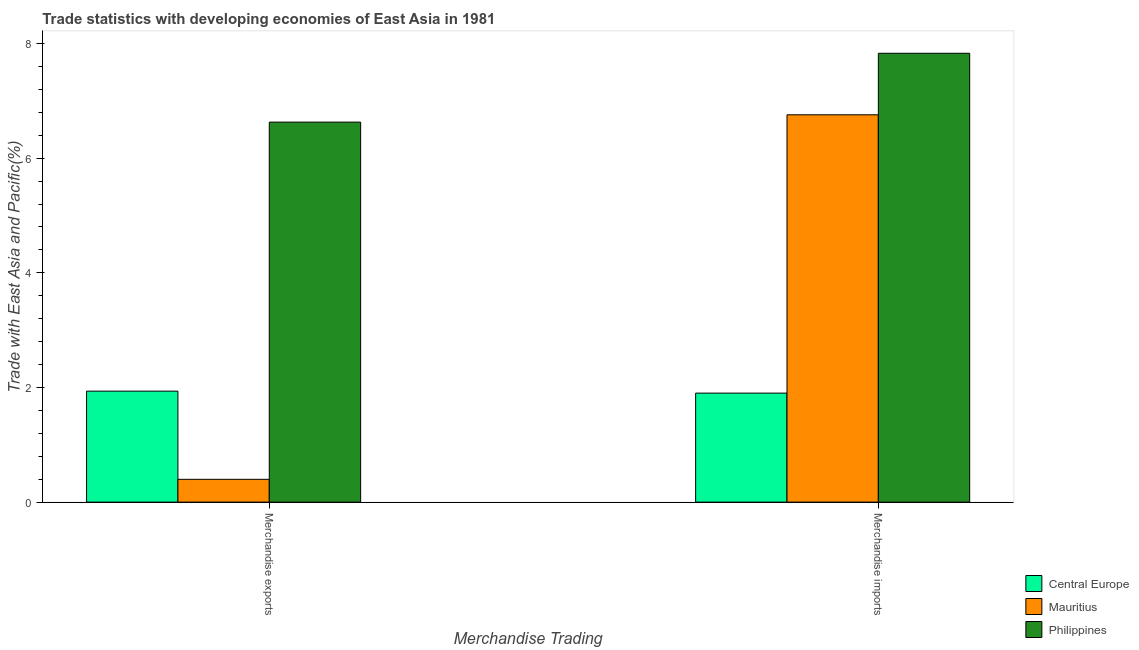How many groups of bars are there?
Give a very brief answer. 2. Are the number of bars per tick equal to the number of legend labels?
Ensure brevity in your answer.  Yes. Are the number of bars on each tick of the X-axis equal?
Keep it short and to the point. Yes. How many bars are there on the 1st tick from the right?
Your response must be concise. 3. What is the merchandise imports in Philippines?
Offer a very short reply. 7.83. Across all countries, what is the maximum merchandise exports?
Give a very brief answer. 6.63. Across all countries, what is the minimum merchandise exports?
Provide a short and direct response. 0.4. In which country was the merchandise imports maximum?
Your answer should be very brief. Philippines. In which country was the merchandise exports minimum?
Make the answer very short. Mauritius. What is the total merchandise exports in the graph?
Your answer should be very brief. 8.96. What is the difference between the merchandise imports in Philippines and that in Central Europe?
Offer a very short reply. 5.93. What is the difference between the merchandise imports in Mauritius and the merchandise exports in Central Europe?
Provide a succinct answer. 4.82. What is the average merchandise exports per country?
Ensure brevity in your answer.  2.99. What is the difference between the merchandise exports and merchandise imports in Mauritius?
Your response must be concise. -6.36. In how many countries, is the merchandise imports greater than 6.8 %?
Make the answer very short. 1. What is the ratio of the merchandise imports in Mauritius to that in Philippines?
Your answer should be compact. 0.86. Is the merchandise imports in Mauritius less than that in Philippines?
Your answer should be compact. Yes. What does the 2nd bar from the right in Merchandise exports represents?
Keep it short and to the point. Mauritius. Are all the bars in the graph horizontal?
Provide a succinct answer. No. Are the values on the major ticks of Y-axis written in scientific E-notation?
Provide a succinct answer. No. Does the graph contain any zero values?
Your answer should be compact. No. Where does the legend appear in the graph?
Offer a very short reply. Bottom right. How are the legend labels stacked?
Offer a terse response. Vertical. What is the title of the graph?
Your response must be concise. Trade statistics with developing economies of East Asia in 1981. Does "Japan" appear as one of the legend labels in the graph?
Offer a very short reply. No. What is the label or title of the X-axis?
Your answer should be compact. Merchandise Trading. What is the label or title of the Y-axis?
Provide a succinct answer. Trade with East Asia and Pacific(%). What is the Trade with East Asia and Pacific(%) in Central Europe in Merchandise exports?
Give a very brief answer. 1.94. What is the Trade with East Asia and Pacific(%) of Mauritius in Merchandise exports?
Your response must be concise. 0.4. What is the Trade with East Asia and Pacific(%) in Philippines in Merchandise exports?
Give a very brief answer. 6.63. What is the Trade with East Asia and Pacific(%) in Central Europe in Merchandise imports?
Keep it short and to the point. 1.9. What is the Trade with East Asia and Pacific(%) in Mauritius in Merchandise imports?
Your response must be concise. 6.76. What is the Trade with East Asia and Pacific(%) of Philippines in Merchandise imports?
Your answer should be compact. 7.83. Across all Merchandise Trading, what is the maximum Trade with East Asia and Pacific(%) in Central Europe?
Your response must be concise. 1.94. Across all Merchandise Trading, what is the maximum Trade with East Asia and Pacific(%) in Mauritius?
Your answer should be compact. 6.76. Across all Merchandise Trading, what is the maximum Trade with East Asia and Pacific(%) of Philippines?
Provide a succinct answer. 7.83. Across all Merchandise Trading, what is the minimum Trade with East Asia and Pacific(%) in Central Europe?
Provide a short and direct response. 1.9. Across all Merchandise Trading, what is the minimum Trade with East Asia and Pacific(%) in Mauritius?
Give a very brief answer. 0.4. Across all Merchandise Trading, what is the minimum Trade with East Asia and Pacific(%) in Philippines?
Make the answer very short. 6.63. What is the total Trade with East Asia and Pacific(%) of Central Europe in the graph?
Your response must be concise. 3.84. What is the total Trade with East Asia and Pacific(%) in Mauritius in the graph?
Provide a succinct answer. 7.15. What is the total Trade with East Asia and Pacific(%) of Philippines in the graph?
Make the answer very short. 14.46. What is the difference between the Trade with East Asia and Pacific(%) in Central Europe in Merchandise exports and that in Merchandise imports?
Your response must be concise. 0.03. What is the difference between the Trade with East Asia and Pacific(%) of Mauritius in Merchandise exports and that in Merchandise imports?
Offer a very short reply. -6.36. What is the difference between the Trade with East Asia and Pacific(%) of Philippines in Merchandise exports and that in Merchandise imports?
Your answer should be compact. -1.2. What is the difference between the Trade with East Asia and Pacific(%) of Central Europe in Merchandise exports and the Trade with East Asia and Pacific(%) of Mauritius in Merchandise imports?
Keep it short and to the point. -4.82. What is the difference between the Trade with East Asia and Pacific(%) in Central Europe in Merchandise exports and the Trade with East Asia and Pacific(%) in Philippines in Merchandise imports?
Offer a terse response. -5.89. What is the difference between the Trade with East Asia and Pacific(%) in Mauritius in Merchandise exports and the Trade with East Asia and Pacific(%) in Philippines in Merchandise imports?
Make the answer very short. -7.43. What is the average Trade with East Asia and Pacific(%) of Central Europe per Merchandise Trading?
Ensure brevity in your answer.  1.92. What is the average Trade with East Asia and Pacific(%) of Mauritius per Merchandise Trading?
Keep it short and to the point. 3.58. What is the average Trade with East Asia and Pacific(%) in Philippines per Merchandise Trading?
Ensure brevity in your answer.  7.23. What is the difference between the Trade with East Asia and Pacific(%) in Central Europe and Trade with East Asia and Pacific(%) in Mauritius in Merchandise exports?
Provide a succinct answer. 1.54. What is the difference between the Trade with East Asia and Pacific(%) of Central Europe and Trade with East Asia and Pacific(%) of Philippines in Merchandise exports?
Make the answer very short. -4.69. What is the difference between the Trade with East Asia and Pacific(%) of Mauritius and Trade with East Asia and Pacific(%) of Philippines in Merchandise exports?
Offer a very short reply. -6.23. What is the difference between the Trade with East Asia and Pacific(%) of Central Europe and Trade with East Asia and Pacific(%) of Mauritius in Merchandise imports?
Offer a terse response. -4.86. What is the difference between the Trade with East Asia and Pacific(%) of Central Europe and Trade with East Asia and Pacific(%) of Philippines in Merchandise imports?
Ensure brevity in your answer.  -5.93. What is the difference between the Trade with East Asia and Pacific(%) in Mauritius and Trade with East Asia and Pacific(%) in Philippines in Merchandise imports?
Provide a succinct answer. -1.07. What is the ratio of the Trade with East Asia and Pacific(%) in Central Europe in Merchandise exports to that in Merchandise imports?
Your answer should be very brief. 1.02. What is the ratio of the Trade with East Asia and Pacific(%) of Mauritius in Merchandise exports to that in Merchandise imports?
Provide a short and direct response. 0.06. What is the ratio of the Trade with East Asia and Pacific(%) of Philippines in Merchandise exports to that in Merchandise imports?
Your answer should be compact. 0.85. What is the difference between the highest and the second highest Trade with East Asia and Pacific(%) of Central Europe?
Provide a short and direct response. 0.03. What is the difference between the highest and the second highest Trade with East Asia and Pacific(%) in Mauritius?
Give a very brief answer. 6.36. What is the difference between the highest and the second highest Trade with East Asia and Pacific(%) of Philippines?
Offer a very short reply. 1.2. What is the difference between the highest and the lowest Trade with East Asia and Pacific(%) of Central Europe?
Offer a very short reply. 0.03. What is the difference between the highest and the lowest Trade with East Asia and Pacific(%) in Mauritius?
Keep it short and to the point. 6.36. What is the difference between the highest and the lowest Trade with East Asia and Pacific(%) in Philippines?
Make the answer very short. 1.2. 